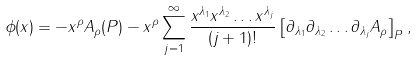Convert formula to latex. <formula><loc_0><loc_0><loc_500><loc_500>\phi ( x ) = - x ^ { \rho } A _ { \rho } ( P ) - x ^ { \rho } \sum _ { j = 1 } ^ { \infty } \frac { x ^ { \lambda _ { 1 } } x ^ { \lambda _ { 2 } } \dots x ^ { \lambda _ { j } } } { ( j + 1 ) ! } \left [ \partial _ { \lambda _ { 1 } } \partial _ { \lambda _ { 2 } } \dots \partial _ { \lambda _ { j } } A _ { \rho } \right ] _ { P } ,</formula> 